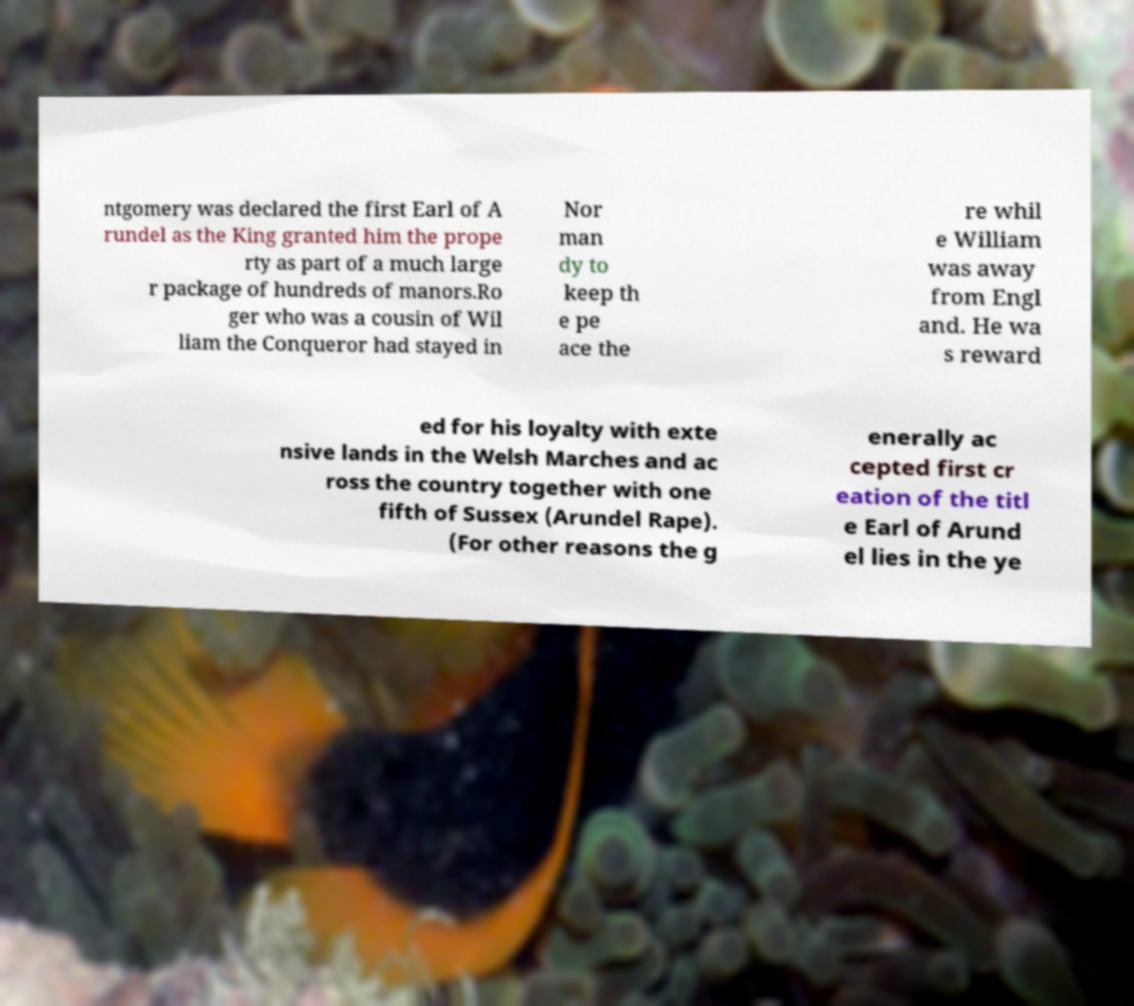Can you read and provide the text displayed in the image?This photo seems to have some interesting text. Can you extract and type it out for me? ntgomery was declared the first Earl of A rundel as the King granted him the prope rty as part of a much large r package of hundreds of manors.Ro ger who was a cousin of Wil liam the Conqueror had stayed in Nor man dy to keep th e pe ace the re whil e William was away from Engl and. He wa s reward ed for his loyalty with exte nsive lands in the Welsh Marches and ac ross the country together with one fifth of Sussex (Arundel Rape). (For other reasons the g enerally ac cepted first cr eation of the titl e Earl of Arund el lies in the ye 